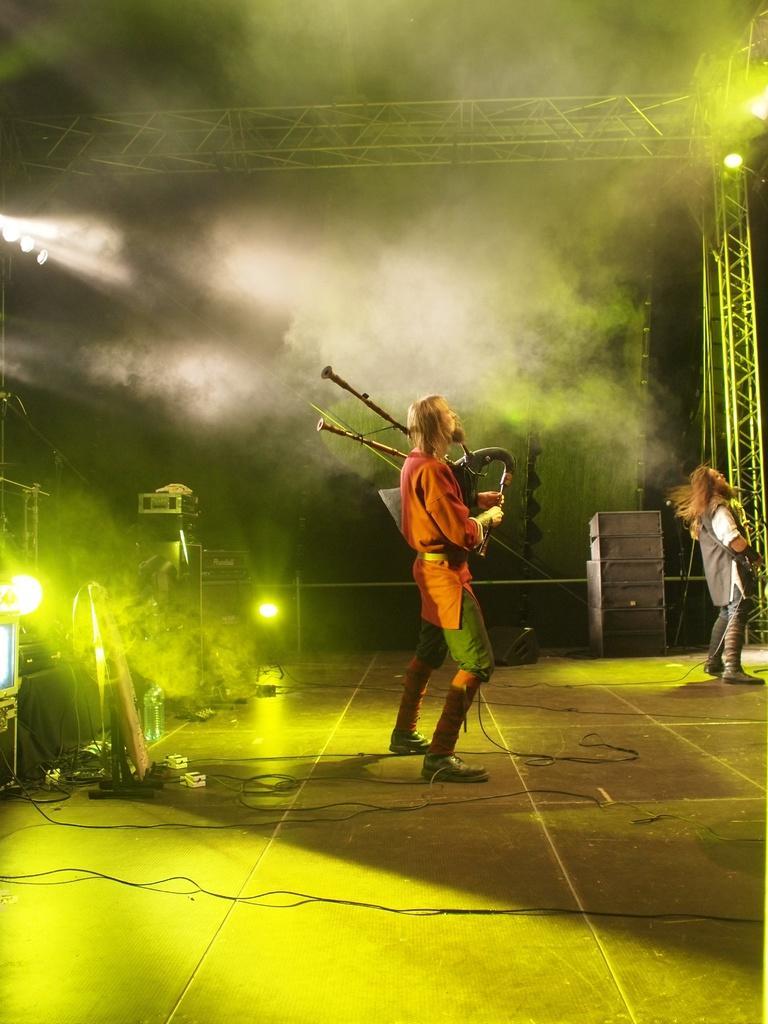Describe this image in one or two sentences. This is a stage. Here I can see two persons standing on the stage facing towards the right side and playing some musical instruments and also there are few cables. On the left side there are few objects and lights in the dark. In the background there is a metal stand and also I can see the fume. 